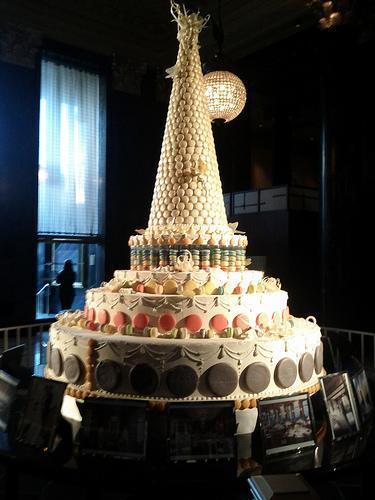How many cakes are there?
Give a very brief answer. 1. 